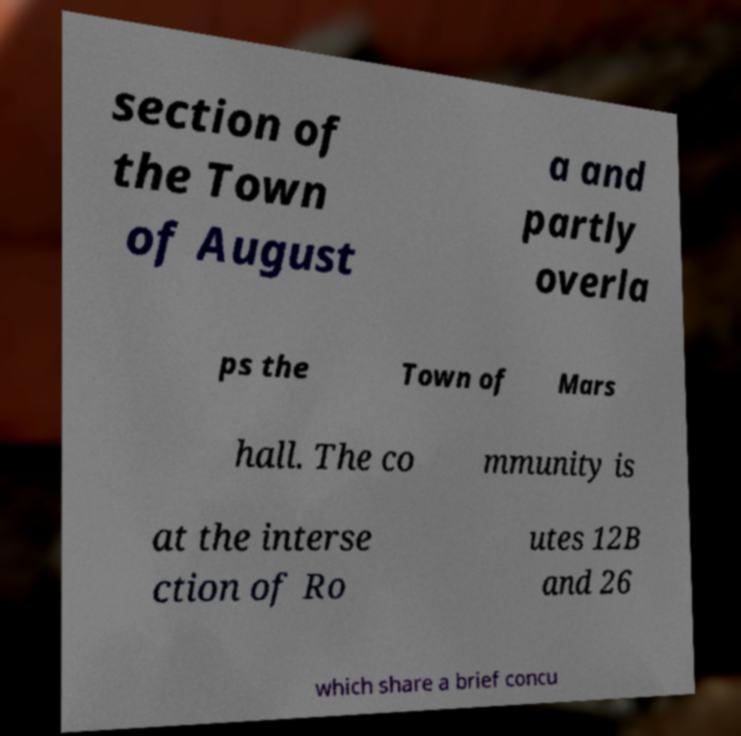Please identify and transcribe the text found in this image. section of the Town of August a and partly overla ps the Town of Mars hall. The co mmunity is at the interse ction of Ro utes 12B and 26 which share a brief concu 